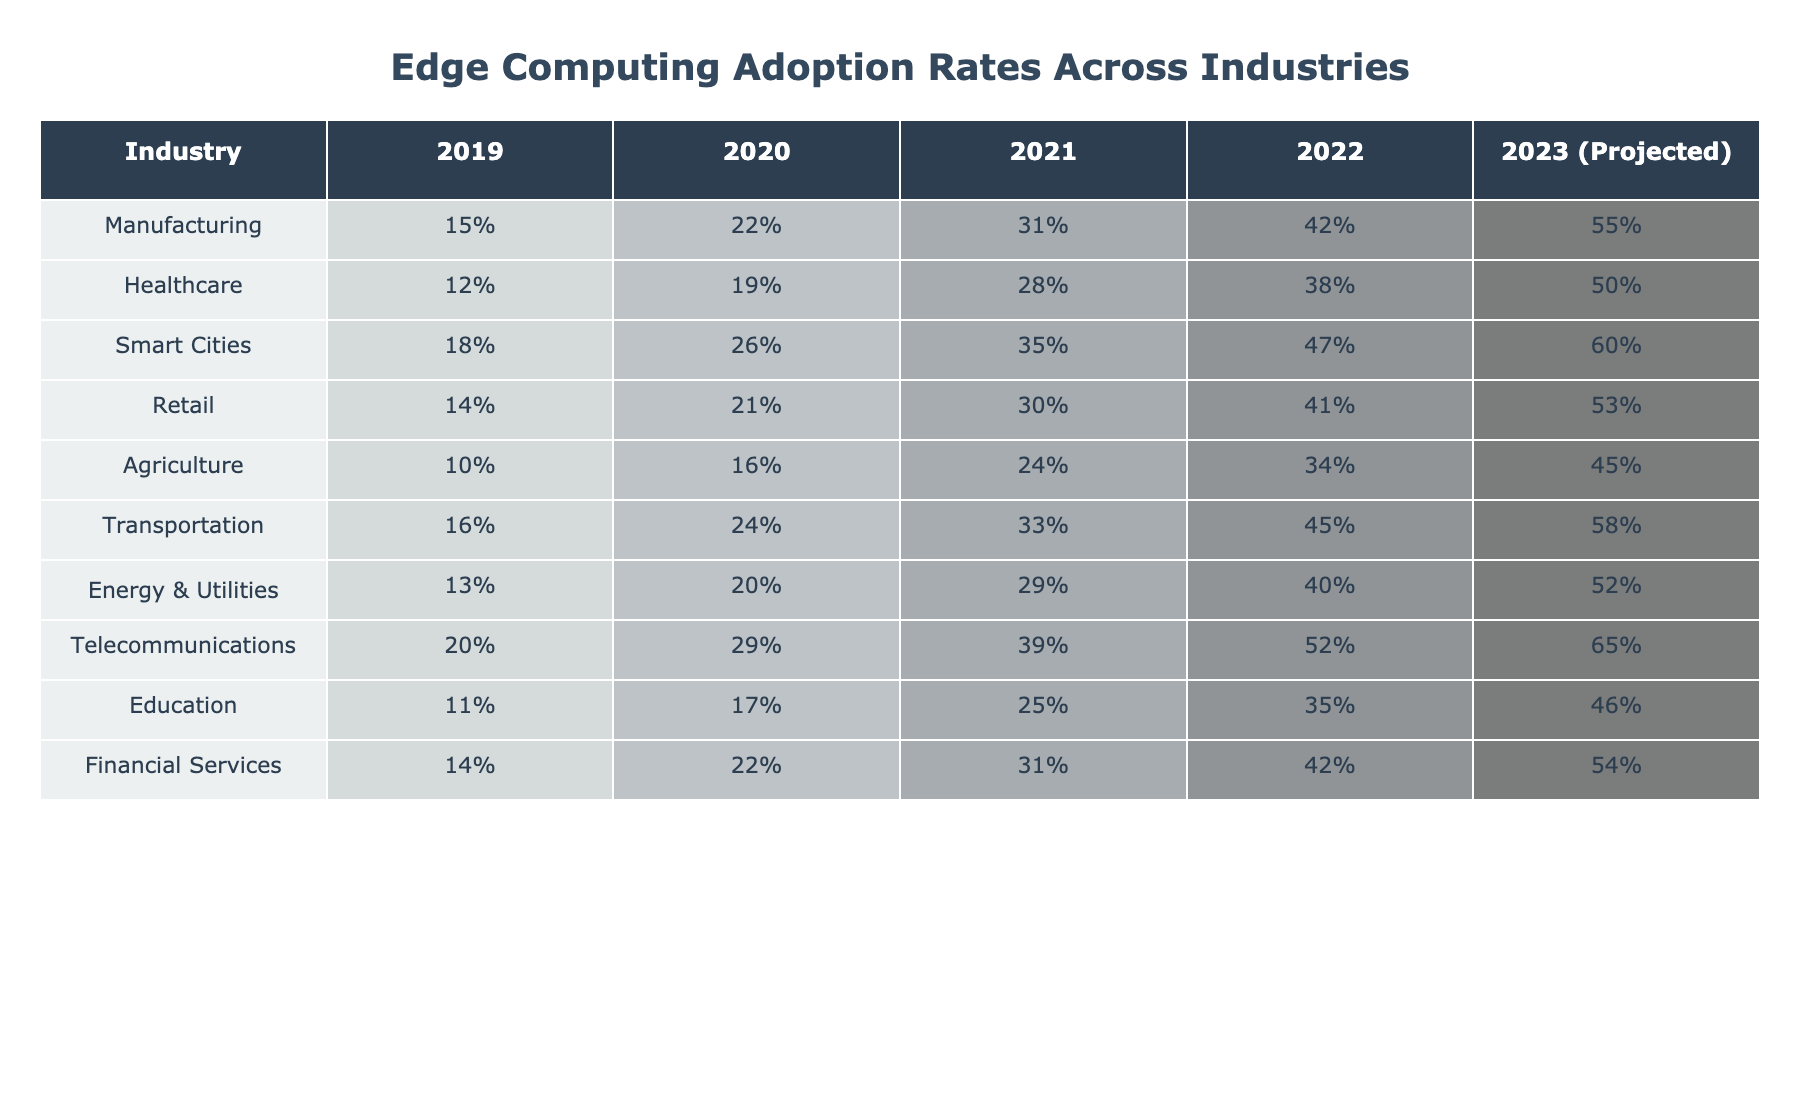What was the adoption rate of edge computing in the healthcare industry in 2022? According to the table, the adoption rate of edge computing in the healthcare industry for 2022 is 38%.
Answer: 38% Which industry had the highest edge computing adoption rate in 2023 (projected)? The table shows that the telecommunications industry has the highest projected adoption rate in 2023 at 65%.
Answer: 65% What is the difference in edge computing adoption rates between the manufacturing and agriculture industries in 2021? For manufacturing, the adoption rate in 2021 is 31%, and for agriculture, it is 24%. The difference is 31% - 24% = 7%.
Answer: 7% Is the edge computing adoption rate in smart cities higher than in transportation for 2022? In 2022, smart cities have an adoption rate of 47%, while transportation has 45%. Since 47% is greater than 45%, the statement is true.
Answer: Yes What are the adoption rates for edge computing in the retail and energy & utilities industries in 2023 (projected), and what is their average? The retail adoption rate for 2023 is 53%, and energy & utilities is 52%. Their average is (53% + 52%) / 2 = 52.5%.
Answer: 52.5% Which two industries saw the largest increase in edge computing adoption rates from 2019 to 2023 (projected)? By comparing the rates from the table, manufacturing increased from 15% to 55% (40% increase) and telecommunications from 20% to 65% (45% increase). Telecommunications had the largest increase.
Answer: Telecommunications and manufacturing What is the trend in edge computing adoption across the educational sector from 2019 to 2023? The adoption rates for education have risen from 11% in 2019 to a projected 46% in 2023, indicating a significant upward trend over these years.
Answer: Upward trend What was the average edge computing adoption rate across all industries in 2022? Adding the 2022 adoption rates for all industries and dividing by the number of industries gives: (42 + 38 + 47 + 41 + 34 + 45 + 40 + 52 + 35 + 42) / 10 = 41.4%.
Answer: 41.4% Which industry had the lowest edge computing adoption rate in 2019? The agriculture industry had the lowest adoption rate in 2019 at 10%.
Answer: 10% What is the projected growth of edge computing adoption in the financial services industry from 2023 to 2022? The projected rate for 2023 is 54%, and for 2022 it is 42%. The growth in adoption is 54% - 42% = 12%.
Answer: 12% 